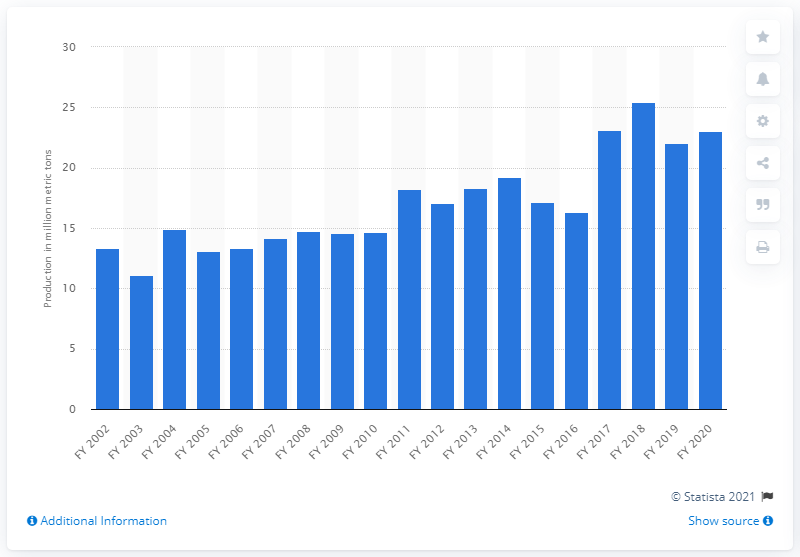Point out several critical features in this image. The estimated production of pulses in India during the financial year 2020 was approximately 23.01 million metric tons. 